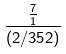<formula> <loc_0><loc_0><loc_500><loc_500>\frac { \frac { 7 } { 1 } } { ( 2 / 3 5 2 ) }</formula> 